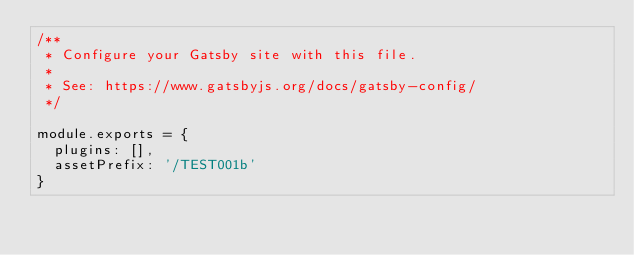<code> <loc_0><loc_0><loc_500><loc_500><_JavaScript_>/**
 * Configure your Gatsby site with this file.
 *
 * See: https://www.gatsbyjs.org/docs/gatsby-config/
 */

module.exports = {
  plugins: [],
  assetPrefix: '/TEST001b'
}
</code> 